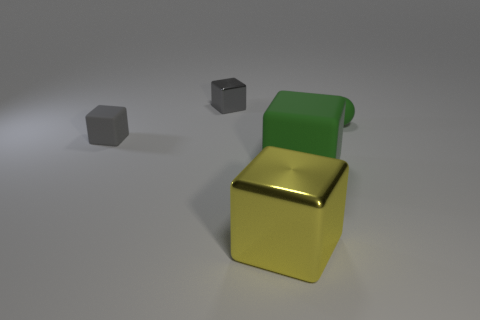Subtract all yellow blocks. How many blocks are left? 3 Subtract all big green blocks. How many blocks are left? 3 Add 2 gray metal objects. How many objects exist? 7 Subtract all blocks. How many objects are left? 1 Subtract 3 cubes. How many cubes are left? 1 Subtract all green blocks. Subtract all green balls. How many blocks are left? 3 Subtract all red cylinders. How many yellow blocks are left? 1 Subtract all tiny green matte balls. Subtract all cubes. How many objects are left? 0 Add 5 big yellow objects. How many big yellow objects are left? 6 Add 4 large brown matte balls. How many large brown matte balls exist? 4 